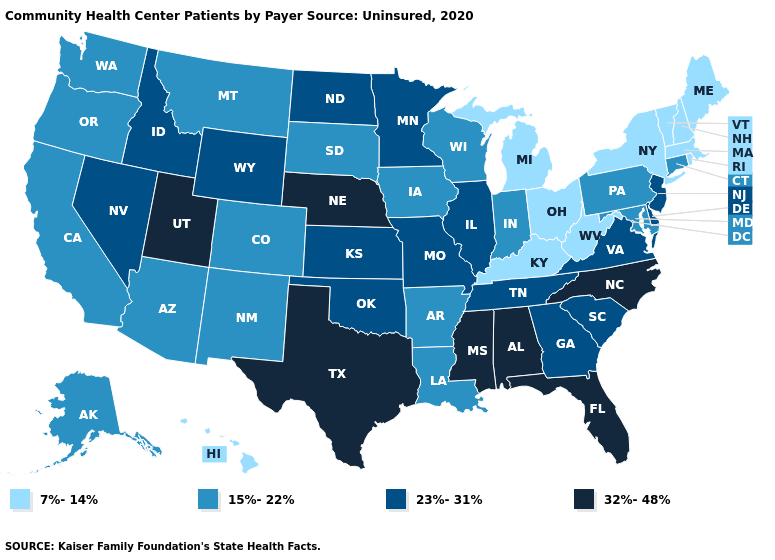What is the highest value in the USA?
Be succinct. 32%-48%. What is the highest value in states that border South Dakota?
Concise answer only. 32%-48%. Name the states that have a value in the range 32%-48%?
Give a very brief answer. Alabama, Florida, Mississippi, Nebraska, North Carolina, Texas, Utah. Name the states that have a value in the range 32%-48%?
Quick response, please. Alabama, Florida, Mississippi, Nebraska, North Carolina, Texas, Utah. What is the value of Nevada?
Keep it brief. 23%-31%. What is the value of North Carolina?
Concise answer only. 32%-48%. Does Hawaii have a lower value than Florida?
Keep it brief. Yes. Does Indiana have the lowest value in the MidWest?
Short answer required. No. Which states have the lowest value in the USA?
Concise answer only. Hawaii, Kentucky, Maine, Massachusetts, Michigan, New Hampshire, New York, Ohio, Rhode Island, Vermont, West Virginia. What is the value of Vermont?
Keep it brief. 7%-14%. Does California have the same value as Kentucky?
Answer briefly. No. What is the highest value in states that border Missouri?
Be succinct. 32%-48%. What is the highest value in the South ?
Keep it brief. 32%-48%. Does Florida have the same value as Texas?
Write a very short answer. Yes. What is the value of Louisiana?
Be succinct. 15%-22%. 